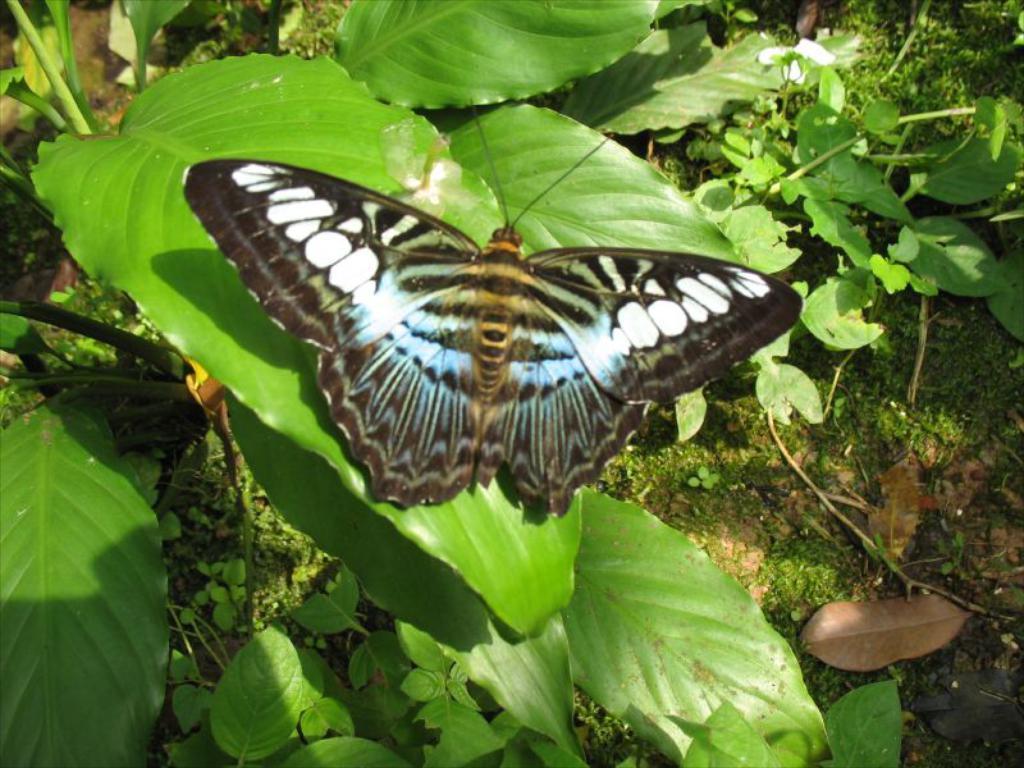How would you summarize this image in a sentence or two? In this image, we can see a butterfly on the leaf. Here we can see few plants with stems and leaves. 